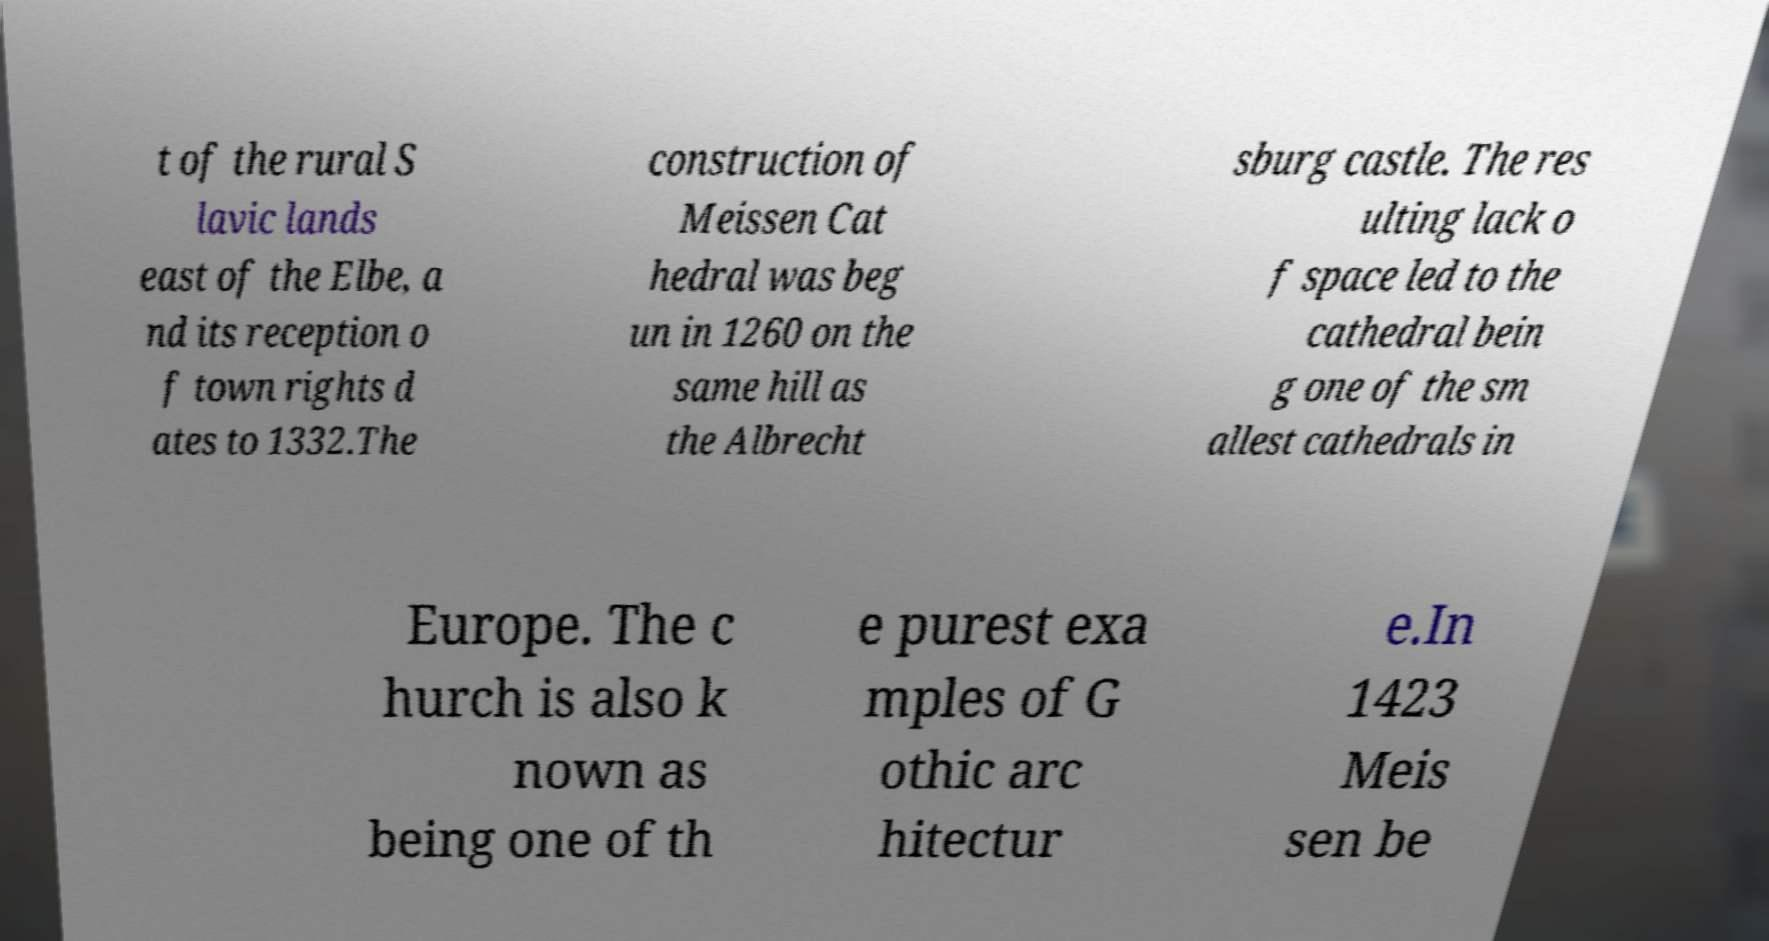What messages or text are displayed in this image? I need them in a readable, typed format. t of the rural S lavic lands east of the Elbe, a nd its reception o f town rights d ates to 1332.The construction of Meissen Cat hedral was beg un in 1260 on the same hill as the Albrecht sburg castle. The res ulting lack o f space led to the cathedral bein g one of the sm allest cathedrals in Europe. The c hurch is also k nown as being one of th e purest exa mples of G othic arc hitectur e.In 1423 Meis sen be 